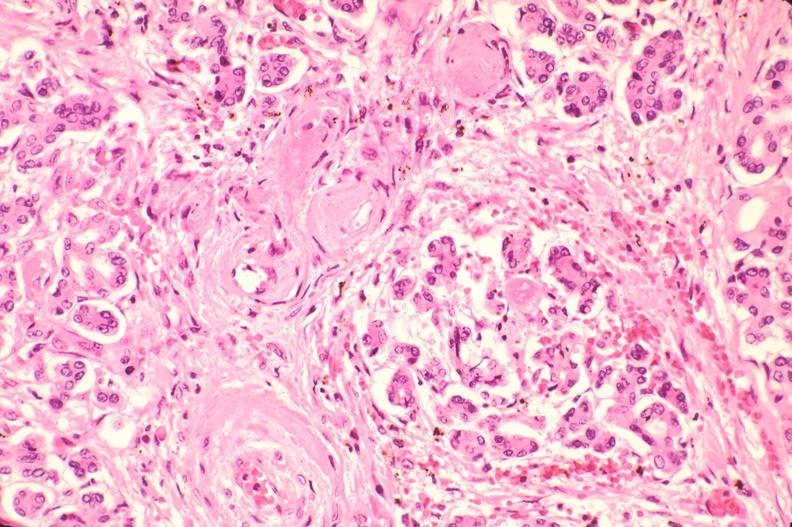where is this part in the figure?
Answer the question using a single word or phrase. Endocrine system 